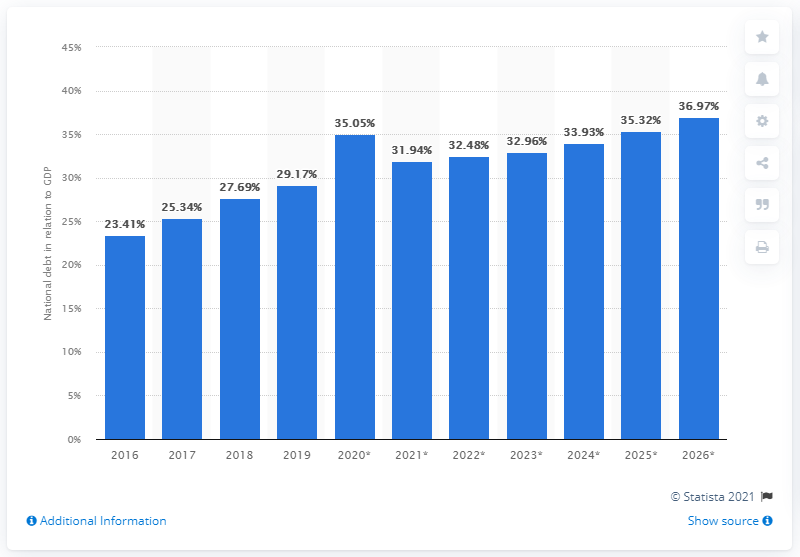Highlight a few significant elements in this photo. In 2019, Nigeria's national debt accounted for 29.17% of the country's Gross Domestic Product (GDP). 